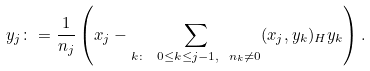<formula> <loc_0><loc_0><loc_500><loc_500>y _ { j } \colon = \frac { 1 } { n _ { j } } \left ( x _ { j } - \sum _ { k \colon \ 0 \leq k \leq j - 1 , \ n _ { k } \not = 0 } ( x _ { j } , y _ { k } ) _ { H } y _ { k } \right ) .</formula> 